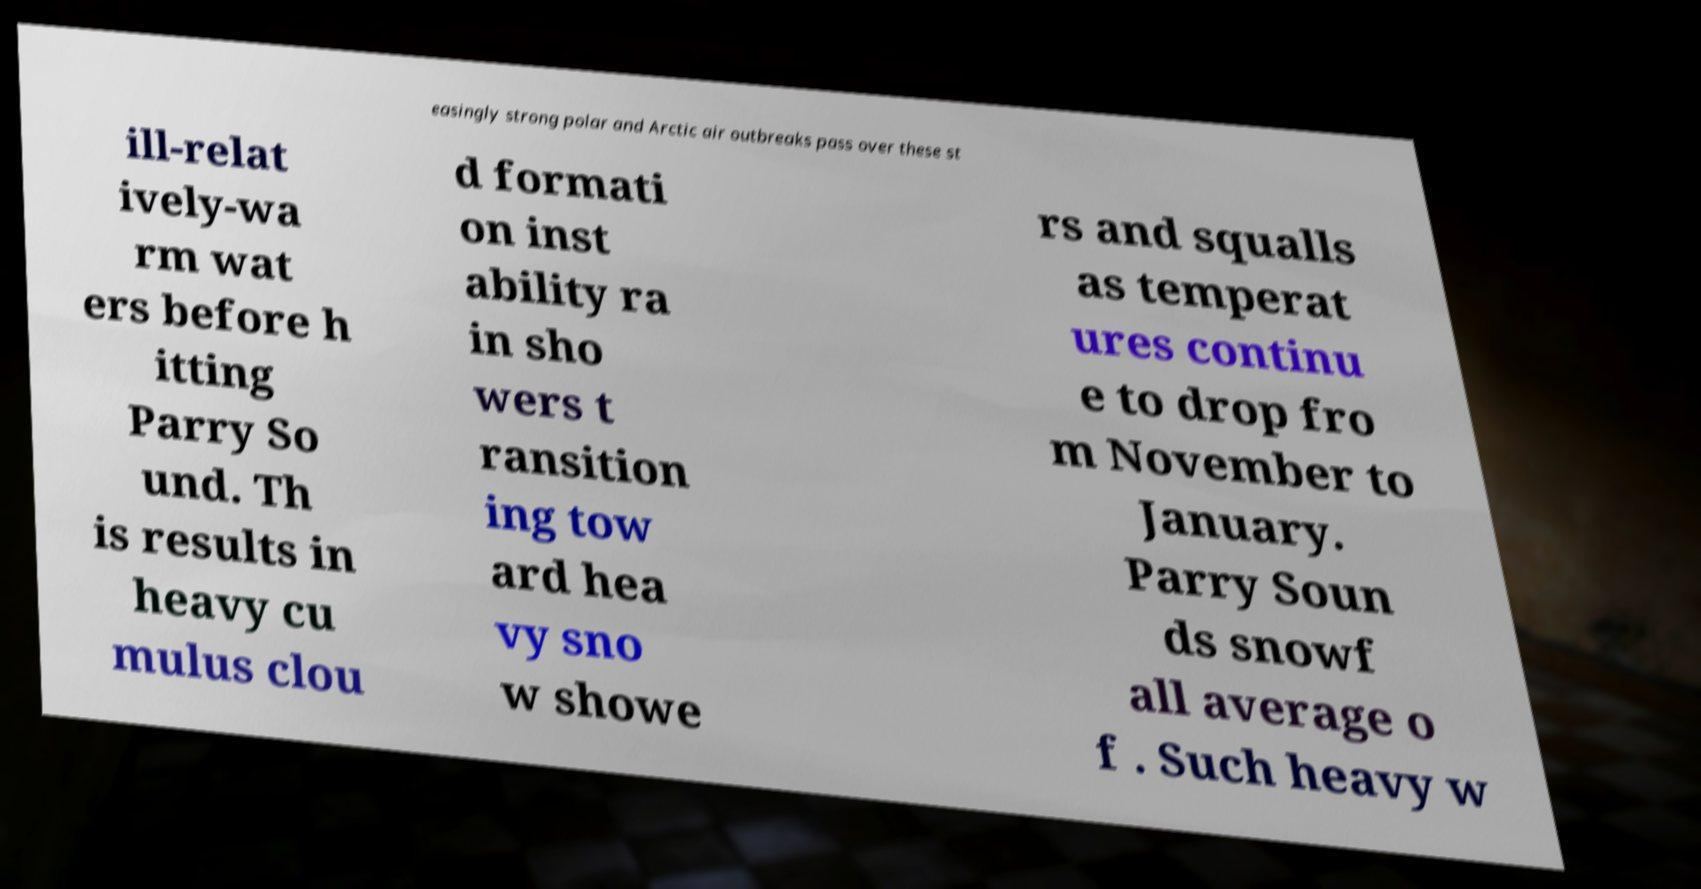Could you extract and type out the text from this image? easingly strong polar and Arctic air outbreaks pass over these st ill-relat ively-wa rm wat ers before h itting Parry So und. Th is results in heavy cu mulus clou d formati on inst ability ra in sho wers t ransition ing tow ard hea vy sno w showe rs and squalls as temperat ures continu e to drop fro m November to January. Parry Soun ds snowf all average o f . Such heavy w 